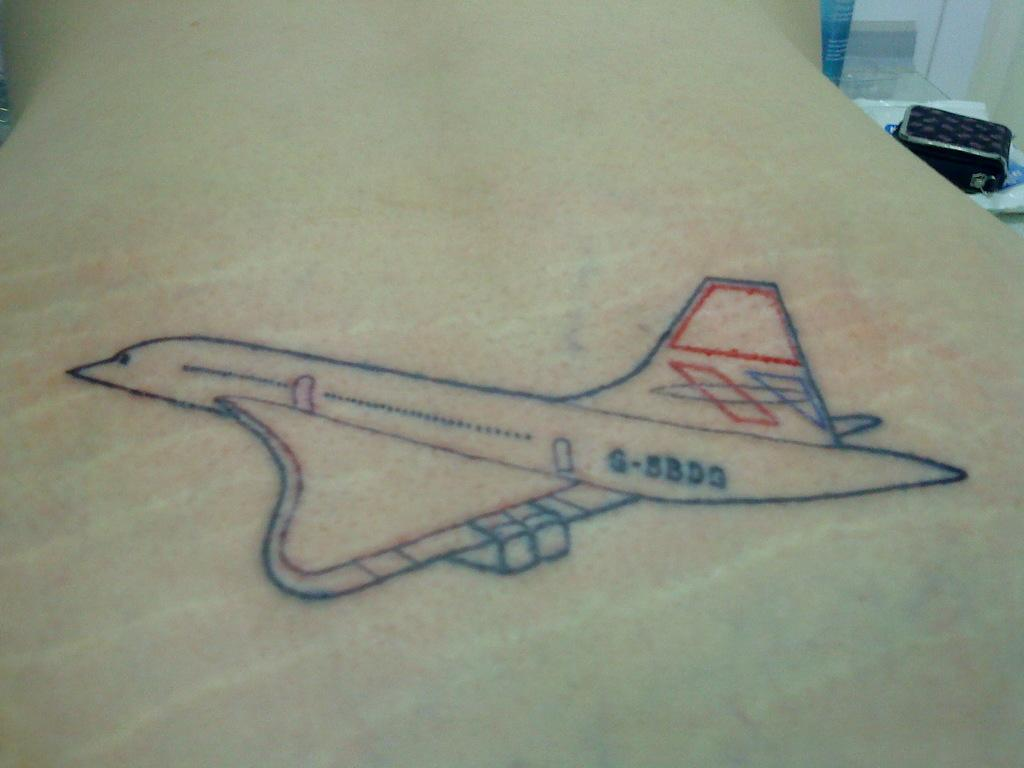<image>
Render a clear and concise summary of the photo. A tattoo of an airplane has 5BD3 written on it. 